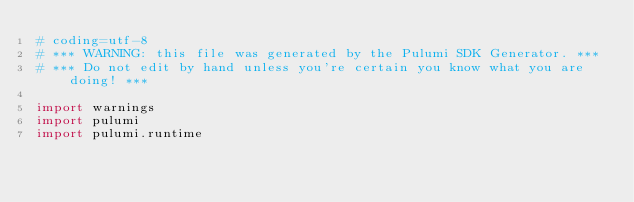<code> <loc_0><loc_0><loc_500><loc_500><_Python_># coding=utf-8
# *** WARNING: this file was generated by the Pulumi SDK Generator. ***
# *** Do not edit by hand unless you're certain you know what you are doing! ***

import warnings
import pulumi
import pulumi.runtime</code> 